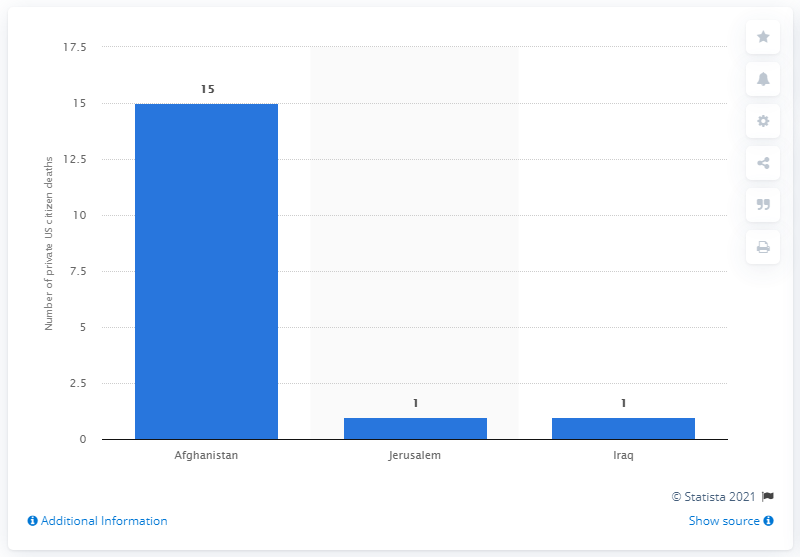Draw attention to some important aspects in this diagram. In 2011, a total of 15 private US citizens were killed in Afghanistan. 